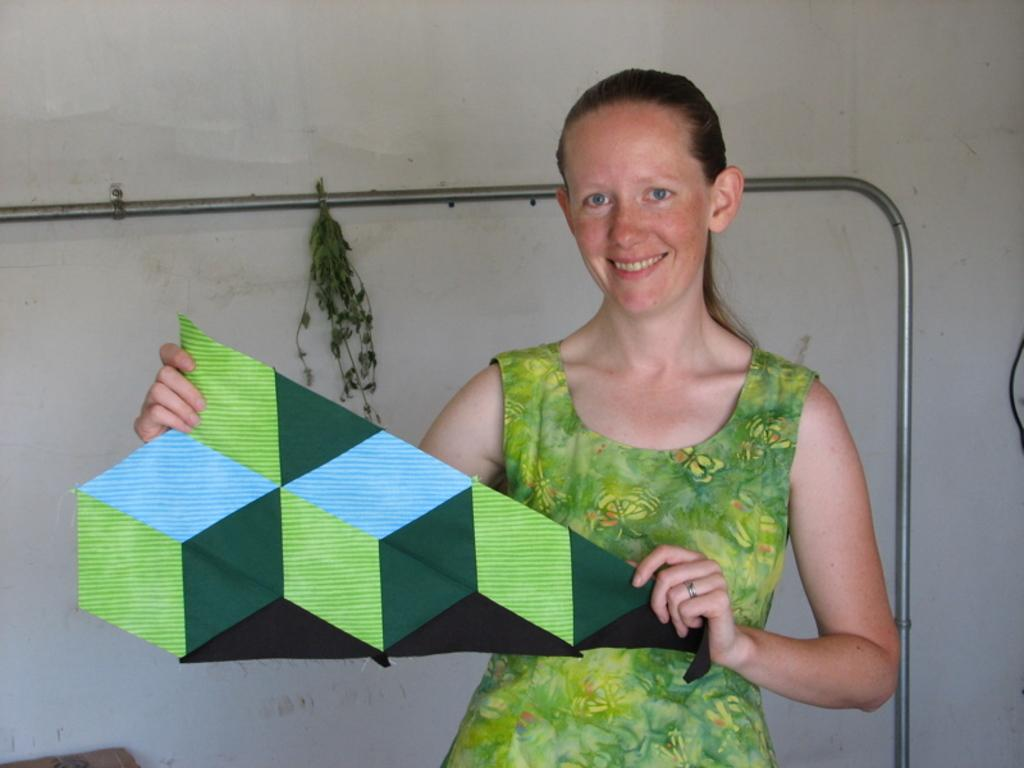Who is present in the image? There is a woman in the image. What is the woman doing in the image? The woman is standing in the image. What is the woman holding in her hands? The woman is holding a cloth in her hands. What can be seen in the background of the image? There is a wall in the background of the image, and there is a pipe on the wall. What type of throne is the woman sitting on in the image? There is no throne present in the image, and the woman is standing, not sitting. 